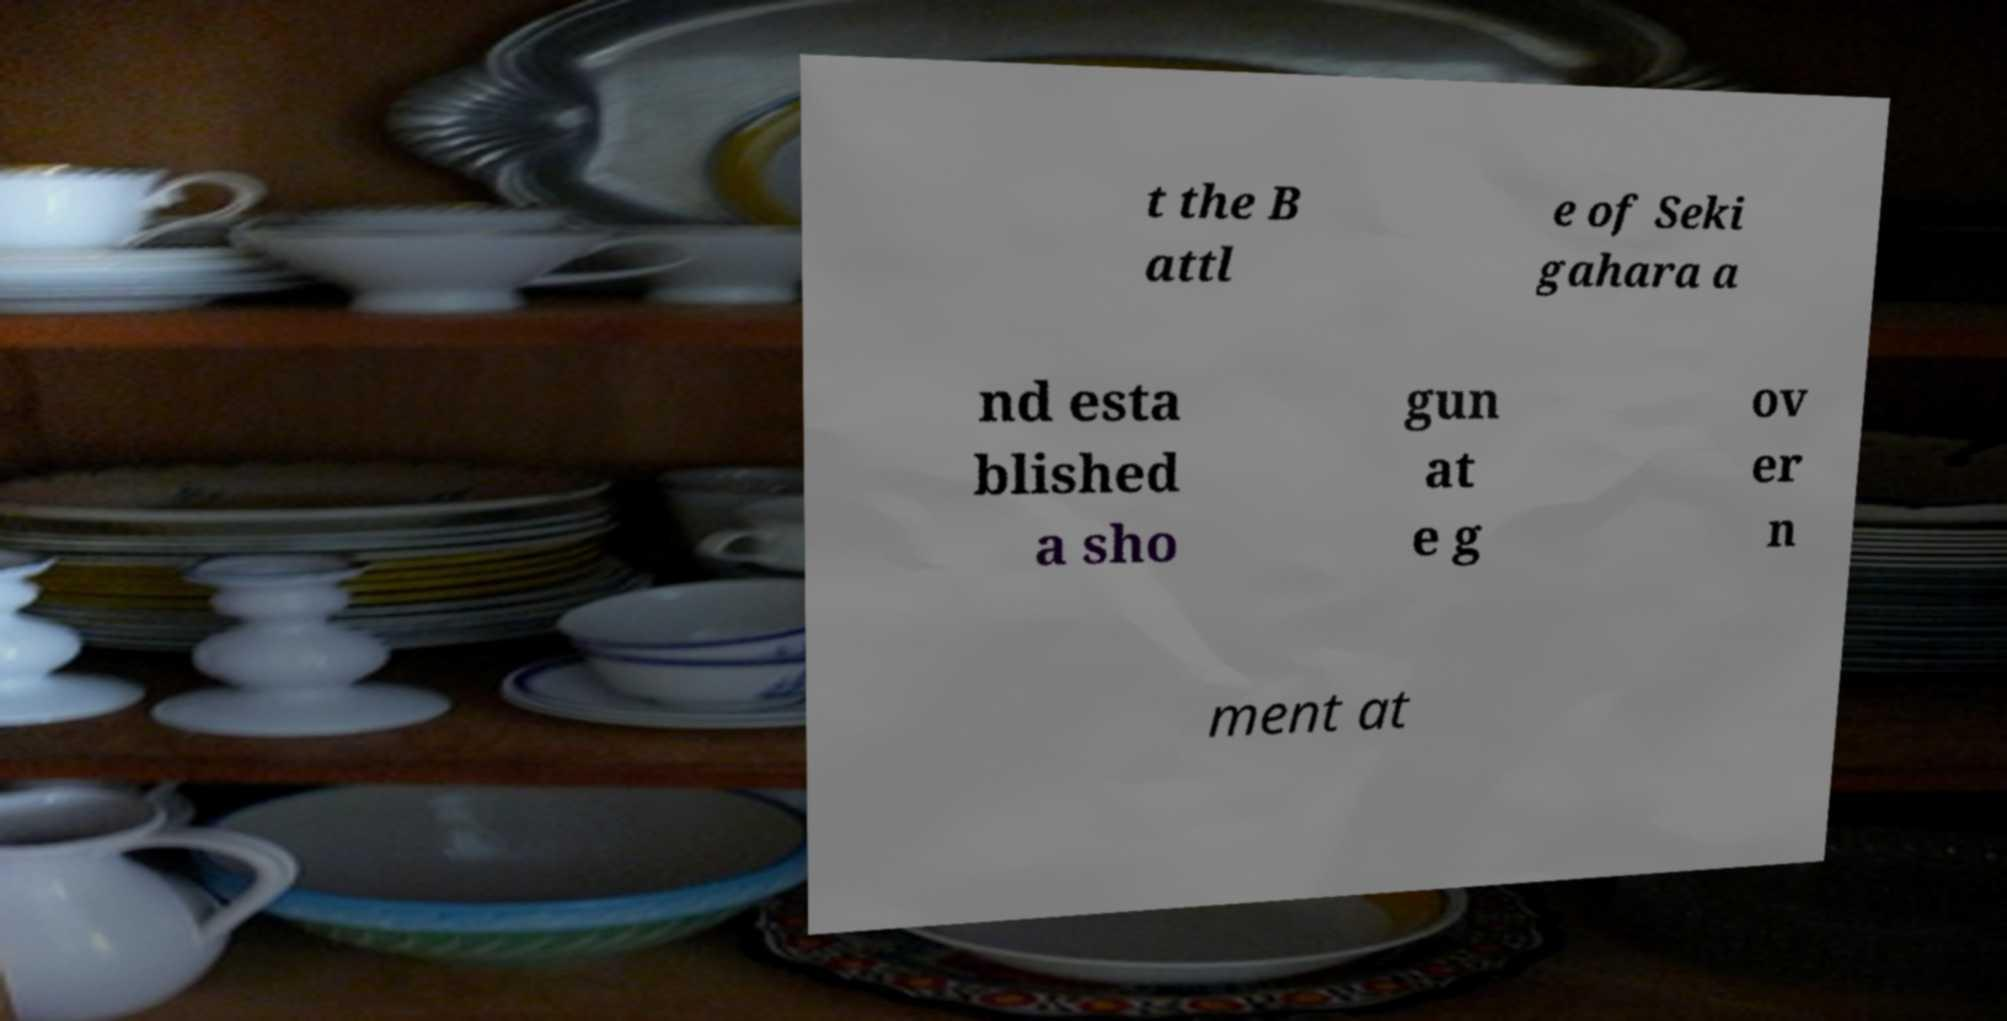Could you extract and type out the text from this image? t the B attl e of Seki gahara a nd esta blished a sho gun at e g ov er n ment at 